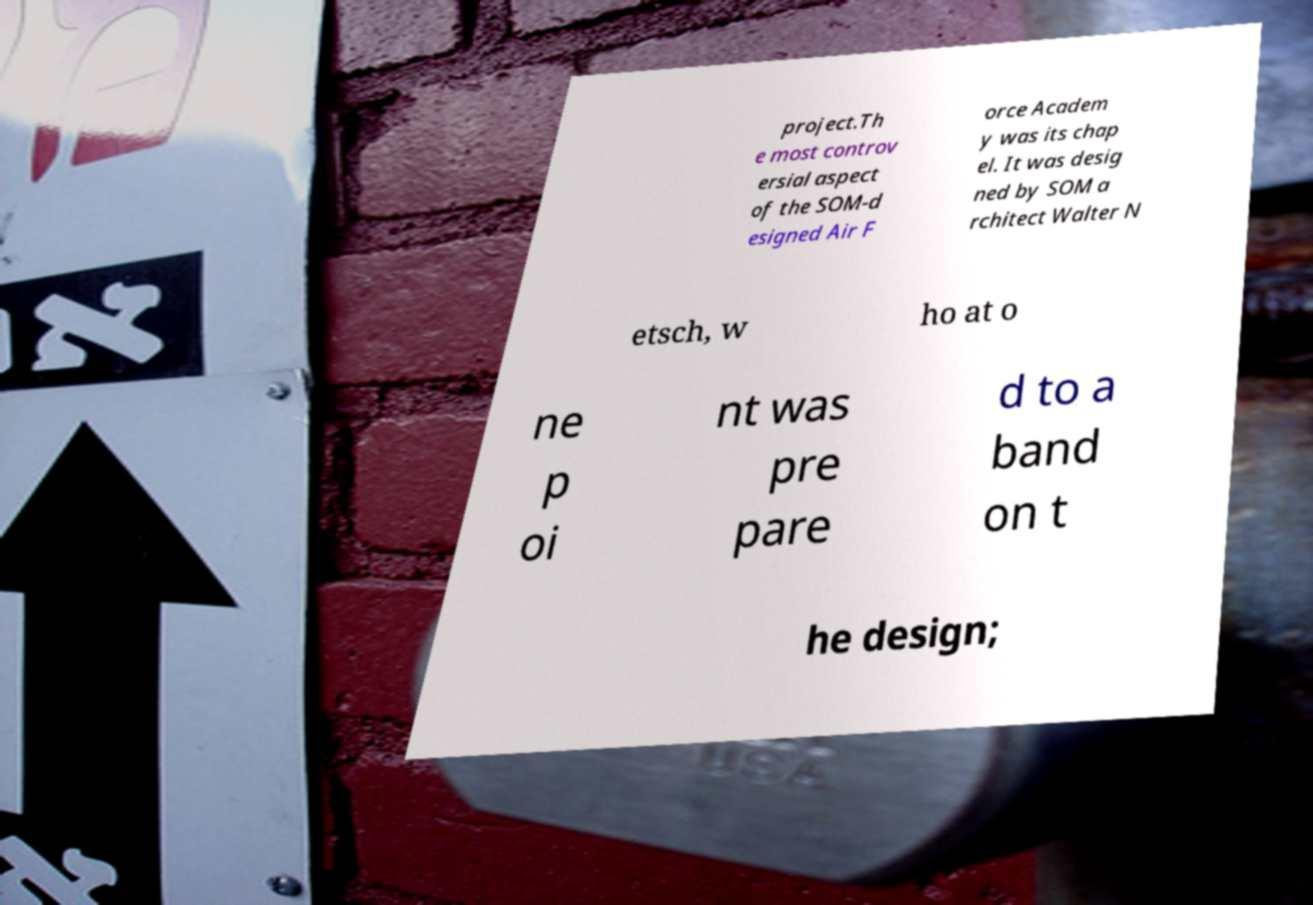What messages or text are displayed in this image? I need them in a readable, typed format. project.Th e most controv ersial aspect of the SOM-d esigned Air F orce Academ y was its chap el. It was desig ned by SOM a rchitect Walter N etsch, w ho at o ne p oi nt was pre pare d to a band on t he design; 